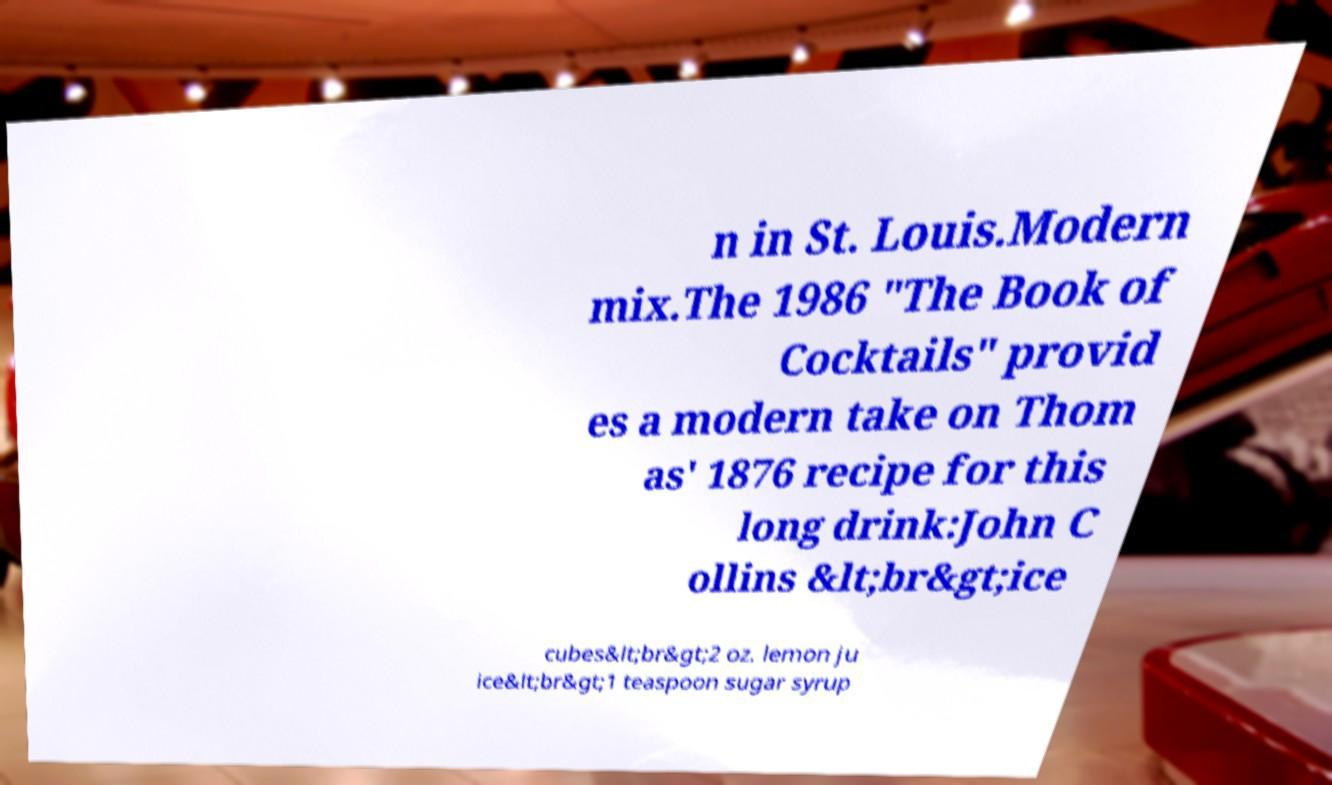There's text embedded in this image that I need extracted. Can you transcribe it verbatim? n in St. Louis.Modern mix.The 1986 "The Book of Cocktails" provid es a modern take on Thom as' 1876 recipe for this long drink:John C ollins &lt;br&gt;ice cubes&lt;br&gt;2 oz. lemon ju ice&lt;br&gt;1 teaspoon sugar syrup 